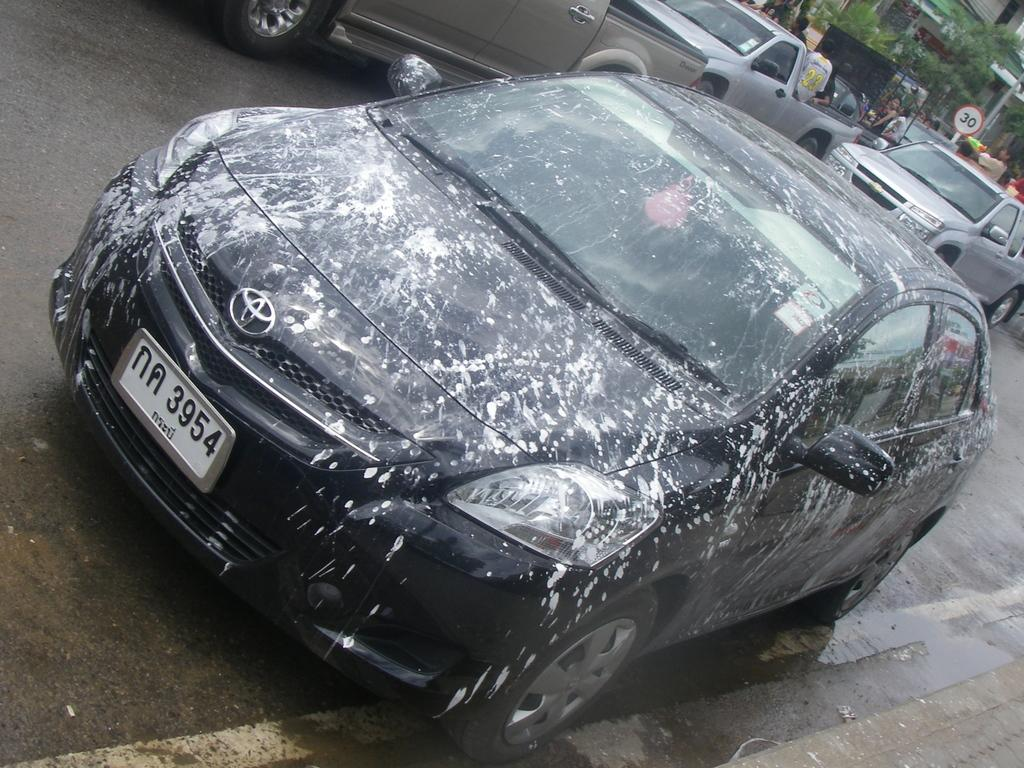What type of vehicle is present in the picture? There is a car in the picture. What other types of vehicles are present in the picture? There are mini trucks in the picture. What structure can be seen in the picture? There is a building in the picture. What natural elements are present in the picture? There are trees in the picture. Are there any people visible in the picture? Yes, there are people standing in the picture. What additional object can be seen in the picture? There is a sign board in the picture. How is the car in the picture decorated? The car has paint on it. What type of chin can be seen on the car in the picture? There is no chin present on the car in the picture. What kind of hook is attached to the mini trucks in the picture? There are no hooks attached to the mini trucks in the picture. 